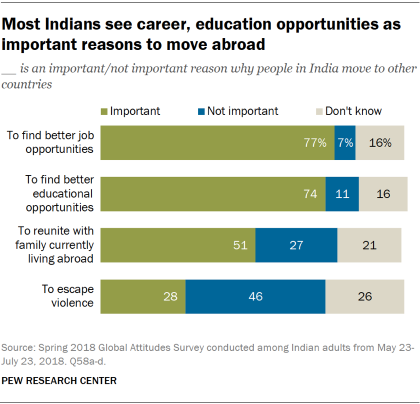Indicate a few pertinent items in this graphic. The color blue does not hold significance The ratio of important to not important in the first bar is 0.459027778... 